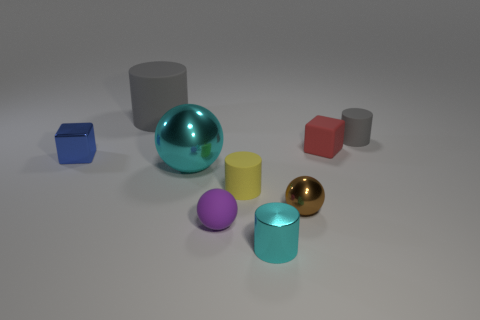What number of small blue matte things are the same shape as the large cyan metal object?
Keep it short and to the point. 0. How many things are either big green metallic balls or objects behind the small gray cylinder?
Provide a succinct answer. 1. There is a large matte cylinder; does it have the same color as the matte thing on the right side of the red thing?
Offer a terse response. Yes. How big is the matte cylinder that is both behind the blue metal thing and left of the small metallic cylinder?
Make the answer very short. Large. There is a purple matte ball; are there any cylinders right of it?
Give a very brief answer. Yes. Are there any matte things that are behind the gray rubber object that is in front of the big gray matte thing?
Your response must be concise. Yes. Are there an equal number of large gray rubber cylinders that are to the left of the large gray cylinder and small purple balls right of the tiny gray cylinder?
Offer a very short reply. Yes. What color is the other small cylinder that is the same material as the tiny gray cylinder?
Your answer should be very brief. Yellow. Is there a small red block made of the same material as the small blue cube?
Offer a very short reply. No. How many things are large green objects or tiny brown spheres?
Give a very brief answer. 1. 